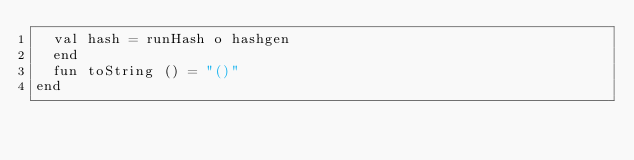<code> <loc_0><loc_0><loc_500><loc_500><_SML_>  val hash = runHash o hashgen
  end
  fun toString () = "()"
end
</code> 